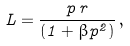<formula> <loc_0><loc_0><loc_500><loc_500>L = \frac { p \, r } { ( 1 + \beta p ^ { 2 } ) } \, ,</formula> 